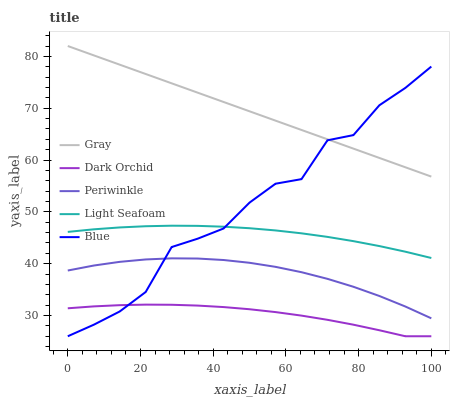Does Dark Orchid have the minimum area under the curve?
Answer yes or no. Yes. Does Gray have the maximum area under the curve?
Answer yes or no. Yes. Does Light Seafoam have the minimum area under the curve?
Answer yes or no. No. Does Light Seafoam have the maximum area under the curve?
Answer yes or no. No. Is Gray the smoothest?
Answer yes or no. Yes. Is Blue the roughest?
Answer yes or no. Yes. Is Light Seafoam the smoothest?
Answer yes or no. No. Is Light Seafoam the roughest?
Answer yes or no. No. Does Blue have the lowest value?
Answer yes or no. Yes. Does Light Seafoam have the lowest value?
Answer yes or no. No. Does Gray have the highest value?
Answer yes or no. Yes. Does Light Seafoam have the highest value?
Answer yes or no. No. Is Dark Orchid less than Light Seafoam?
Answer yes or no. Yes. Is Gray greater than Periwinkle?
Answer yes or no. Yes. Does Blue intersect Light Seafoam?
Answer yes or no. Yes. Is Blue less than Light Seafoam?
Answer yes or no. No. Is Blue greater than Light Seafoam?
Answer yes or no. No. Does Dark Orchid intersect Light Seafoam?
Answer yes or no. No. 